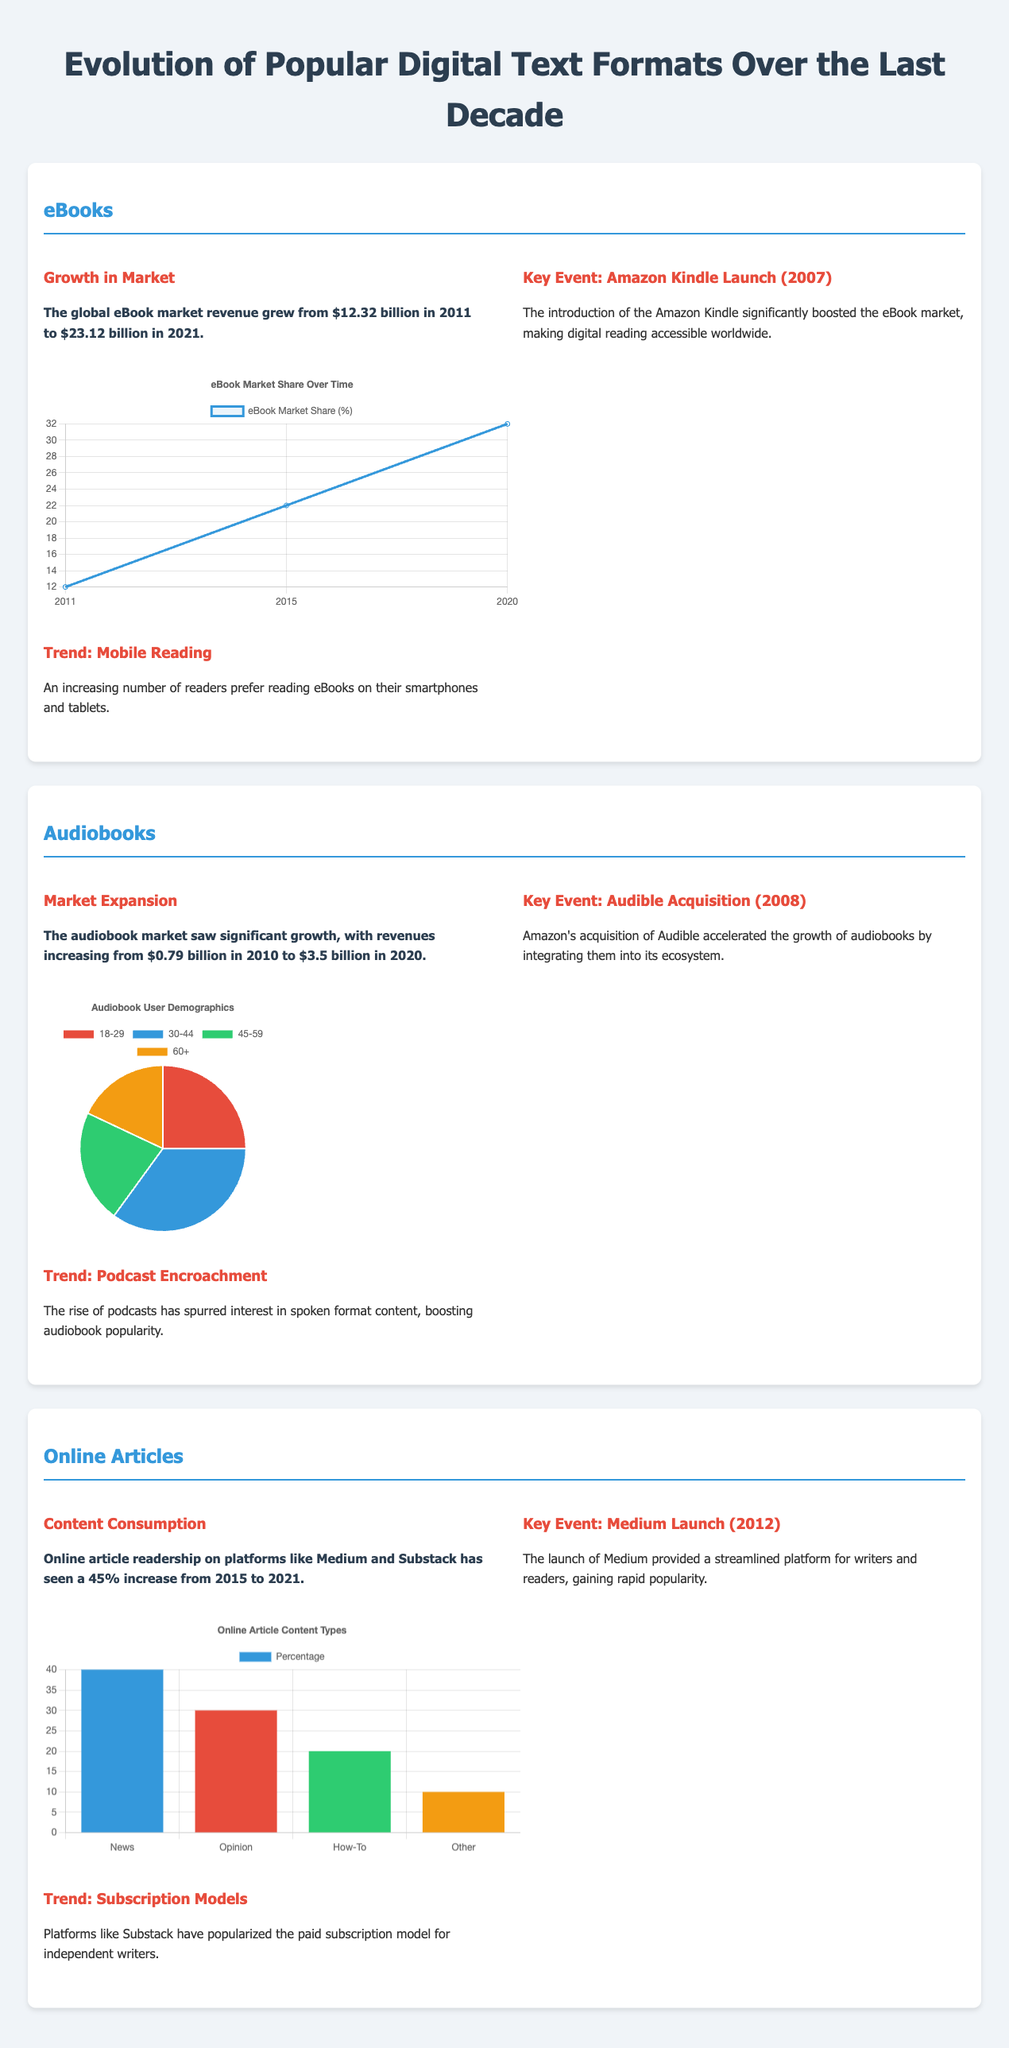What was the eBook market revenue in 2021? The revenue figure is specifically mentioned in the document for 2021, which states $23.12 billion.
Answer: $23.12 billion What significant event happened in 2007 related to eBooks? The document notes that the Amazon Kindle was launched in 2007, which was vital for the eBook market.
Answer: Amazon Kindle Launch What was the growth rate of online article readership from 2015 to 2021? The document states that there was a 45% increase in online article readership during this time frame.
Answer: 45% What percentage of audiobook users are aged 30-44? The document specifies that 35% of audiobook users belong to the 30-44 age group.
Answer: 35% What major trend is associated with audiobooks? A key trend mentioned for audiobooks is the rise of podcasts, which has influenced audiobook popularity.
Answer: Podcast Encroachment What content type has the highest percentage in online articles? The document indicates that News is the most prevalent content type, with 40% representation.
Answer: News What year was Medium launched? The launch year for Medium is directly stated in the document as 2012.
Answer: 2012 How much revenue did the audiobook market generate in 2020? The document explicitly states that audiobook market revenues reached $3.5 billion in 2020.
Answer: $3.5 billion What is the primary trend in mobile reading for eBooks? The document highlights that an increasing number of readers prefer to read eBooks on mobile devices.
Answer: Mobile Reading 